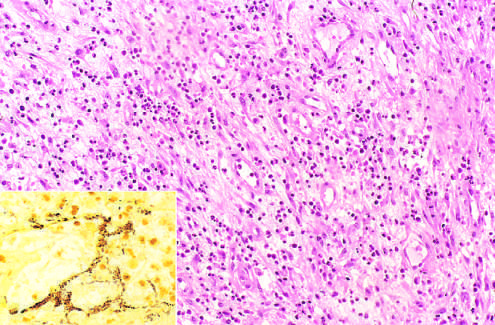does modified silver stain demonstrate clusters of tangled bacilli (black)?
Answer the question using a single word or phrase. Yes 